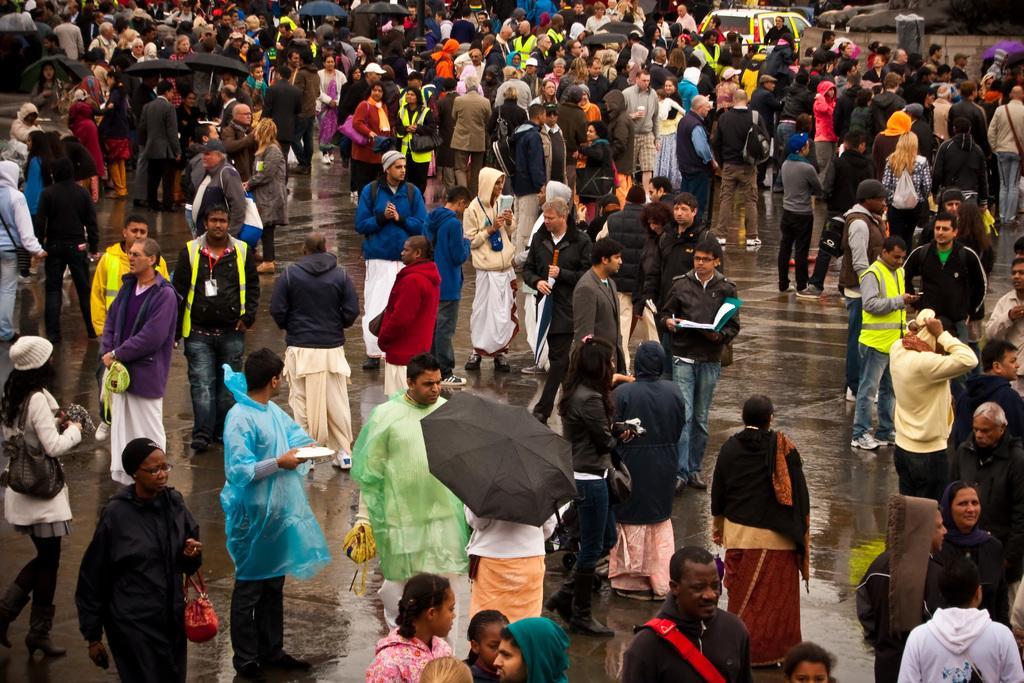Can you describe this image briefly? In this image we can see a group of people wearing dress are standing on the ground. Some people are holding umbrellas in their hands. One woman is wearing a cap and spectacles is carrying a bag. In the background, we can see a car parked on the road, a statue and a trash bin. 